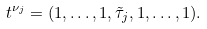<formula> <loc_0><loc_0><loc_500><loc_500>t ^ { \nu _ { j } } = ( 1 , \dots , 1 , \tilde { \tau } _ { j } , 1 , \dots , 1 ) .</formula> 